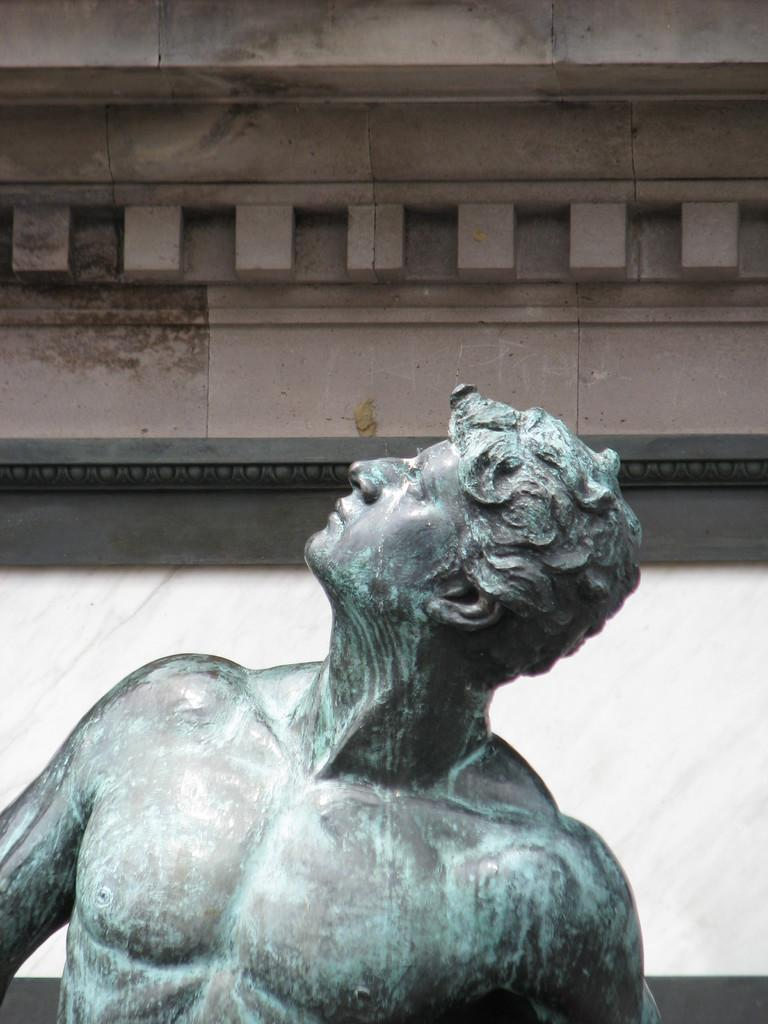What is the main subject of the image? There is a statue in the image. Can you describe the statue's surroundings? There is a wall in the background of the image. How much money is being exchanged between the statue and the wall in the image? There is no exchange of money between the statue and the wall in the image, as it is not a transactional scene. 